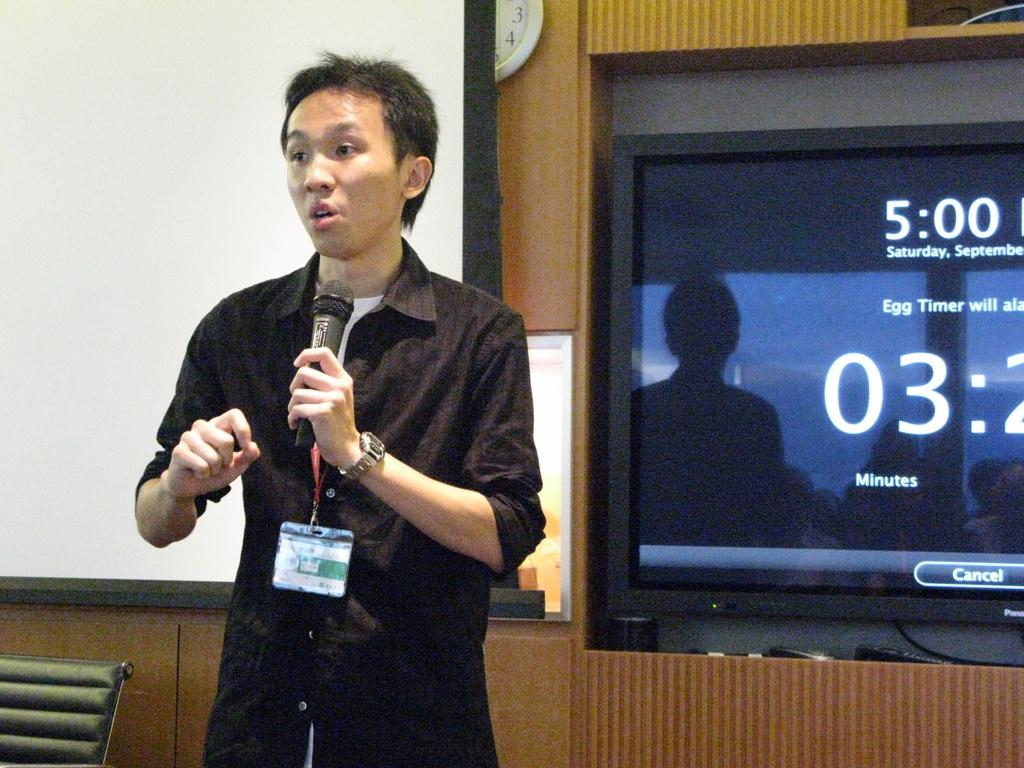What is the man in the image doing? The man is standing and talking in the image. What is the man holding in the image? The man is holding a microphone in the image. Can you describe the man's attire in the image? The man is wearing a tag in the image. What can be seen in the background of the image? There is a white banner, a clock on a wall, and a television in the background of the image. What type of temper can be seen on the man's face in the image? There is no indication of the man's temper in the image; we can only see that he is talking and holding a microphone. 